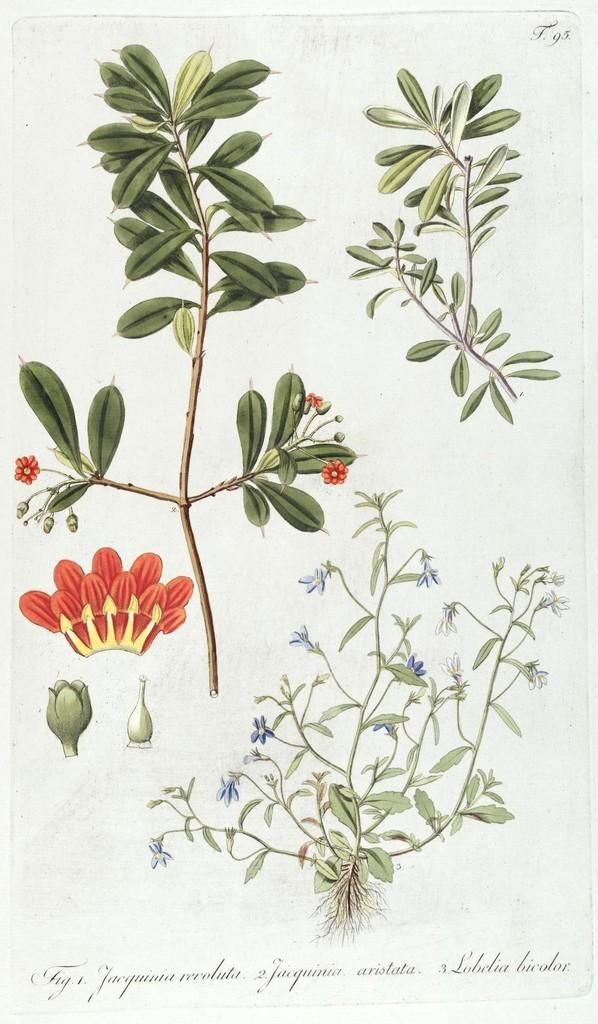What is the main subject of the image? There is a painting in the image. What is being depicted in the painting? The painting depicts plants with flowers. Are there any words or letters in the painting? Yes, there is text present in the painting. What type of vegetable is being cooked in the oven in the image? There is no oven or vegetable present in the image; it features a painting of plants with flowers and text. 